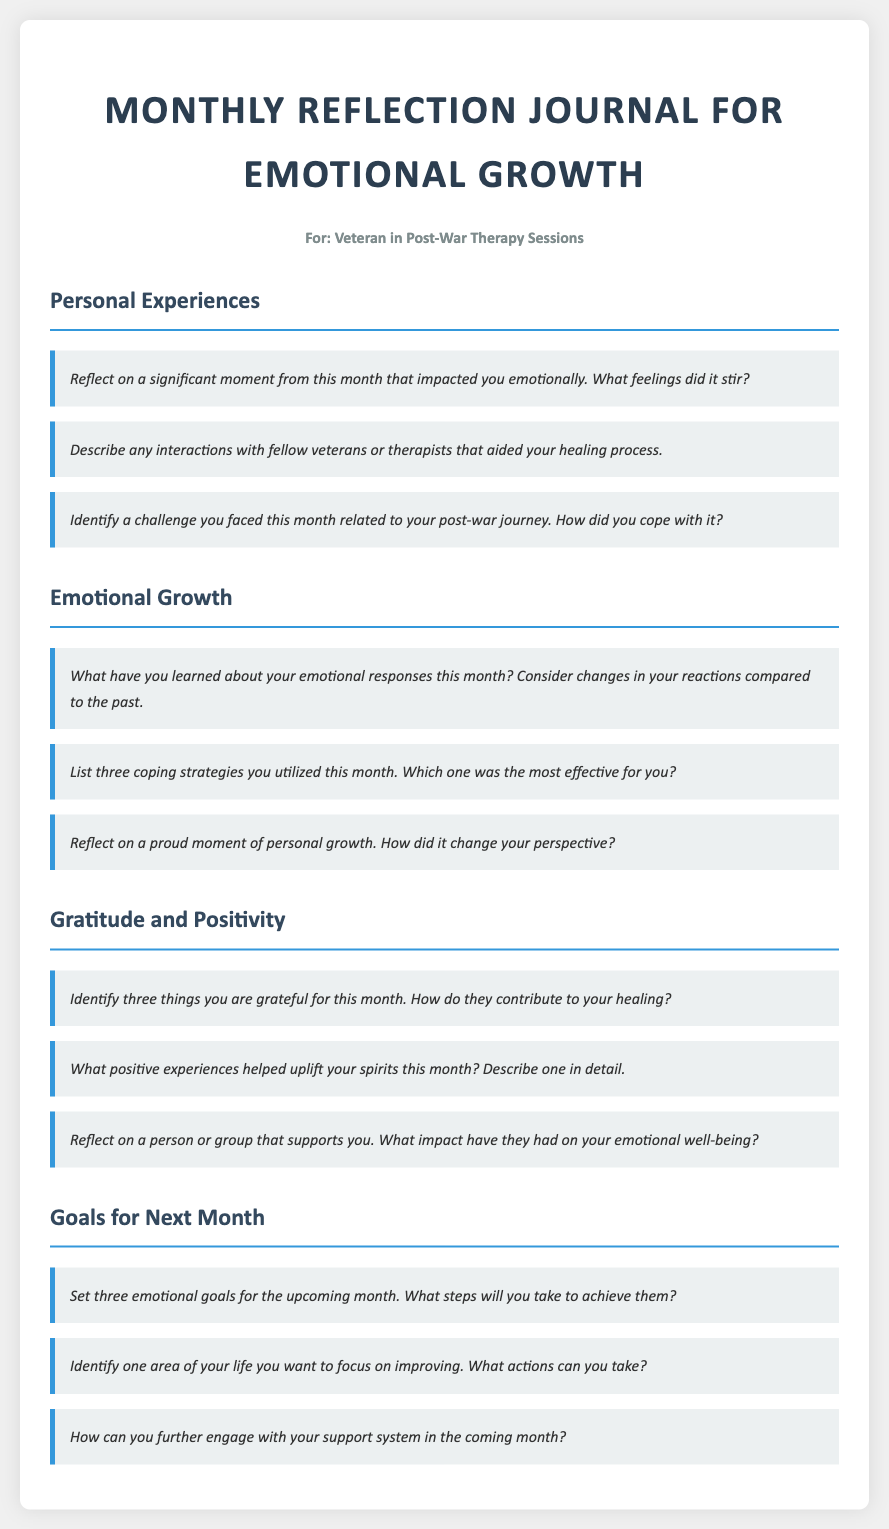What is the title of the document? The title is specified in the head section of the HTML document.
Answer: Monthly Reflection Journal for Emotional Growth Who is the target audience for this journal? The target audience is mentioned in the persona section of the document.
Answer: Veteran in Post-War Therapy Sessions How many sections are in the journal? The document indicates the main topics being divided into sections, which counts them.
Answer: Four What is the first prompt under "Emotional Growth"? The first prompt is the first item listed in the "Emotional Growth" section.
Answer: What have you learned about your emotional responses this month? List one area the journal prompts focus on. The prompts are categorized into sections that reflect different aspects of emotional well-being.
Answer: Gratitude and Positivity How many coping strategies should be listed under "Emotional Growth"? The document specifies how many coping strategies the reader should enumerate in the prompts.
Answer: Three What should be identified under "Goals for Next Month"? The "Goals for Next Month" section details what the user is encouraged to set and categorize.
Answer: Three emotional goals What type of experiences are suggested to uplift spirits? The prompts under the related section specifically ask for a type that contributes positively.
Answer: Positive experiences 